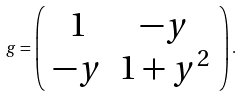Convert formula to latex. <formula><loc_0><loc_0><loc_500><loc_500>g = \left ( \begin{array} { c c } 1 & - y \\ - y & 1 + y ^ { 2 } \\ \end{array} \right ) .</formula> 